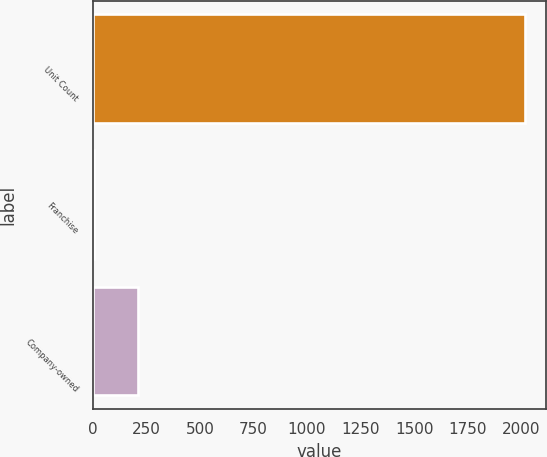Convert chart. <chart><loc_0><loc_0><loc_500><loc_500><bar_chart><fcel>Unit Count<fcel>Franchise<fcel>Company-owned<nl><fcel>2017<fcel>8<fcel>208.9<nl></chart> 